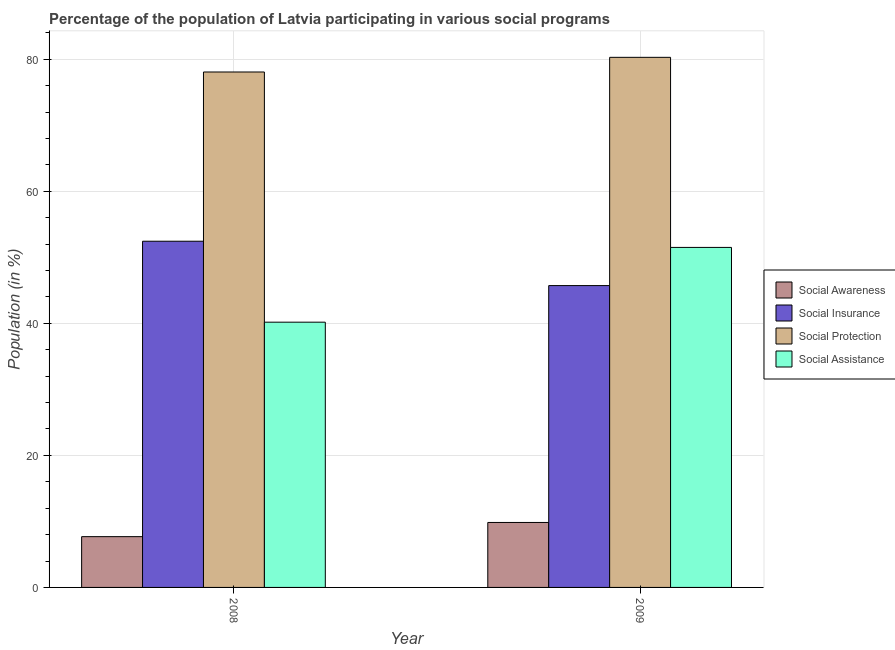How many different coloured bars are there?
Give a very brief answer. 4. How many groups of bars are there?
Your response must be concise. 2. Are the number of bars per tick equal to the number of legend labels?
Provide a succinct answer. Yes. How many bars are there on the 1st tick from the left?
Give a very brief answer. 4. How many bars are there on the 1st tick from the right?
Provide a succinct answer. 4. In how many cases, is the number of bars for a given year not equal to the number of legend labels?
Your answer should be compact. 0. What is the participation of population in social insurance programs in 2008?
Offer a terse response. 52.44. Across all years, what is the maximum participation of population in social insurance programs?
Your answer should be very brief. 52.44. Across all years, what is the minimum participation of population in social assistance programs?
Offer a terse response. 40.18. In which year was the participation of population in social protection programs maximum?
Ensure brevity in your answer.  2009. What is the total participation of population in social protection programs in the graph?
Make the answer very short. 158.38. What is the difference between the participation of population in social awareness programs in 2008 and that in 2009?
Your answer should be very brief. -2.15. What is the difference between the participation of population in social assistance programs in 2008 and the participation of population in social awareness programs in 2009?
Your answer should be very brief. -11.33. What is the average participation of population in social awareness programs per year?
Your answer should be very brief. 8.77. In how many years, is the participation of population in social insurance programs greater than 12 %?
Provide a succinct answer. 2. What is the ratio of the participation of population in social awareness programs in 2008 to that in 2009?
Give a very brief answer. 0.78. In how many years, is the participation of population in social assistance programs greater than the average participation of population in social assistance programs taken over all years?
Make the answer very short. 1. What does the 3rd bar from the left in 2008 represents?
Provide a short and direct response. Social Protection. What does the 2nd bar from the right in 2009 represents?
Your answer should be very brief. Social Protection. Is it the case that in every year, the sum of the participation of population in social awareness programs and participation of population in social insurance programs is greater than the participation of population in social protection programs?
Provide a short and direct response. No. What is the difference between two consecutive major ticks on the Y-axis?
Give a very brief answer. 20. Does the graph contain any zero values?
Your response must be concise. No. Does the graph contain grids?
Offer a terse response. Yes. Where does the legend appear in the graph?
Provide a succinct answer. Center right. How many legend labels are there?
Your response must be concise. 4. How are the legend labels stacked?
Your answer should be compact. Vertical. What is the title of the graph?
Provide a short and direct response. Percentage of the population of Latvia participating in various social programs . Does "Industry" appear as one of the legend labels in the graph?
Provide a short and direct response. No. What is the label or title of the X-axis?
Provide a succinct answer. Year. What is the Population (in %) in Social Awareness in 2008?
Keep it short and to the point. 7.69. What is the Population (in %) of Social Insurance in 2008?
Provide a succinct answer. 52.44. What is the Population (in %) of Social Protection in 2008?
Your answer should be compact. 78.08. What is the Population (in %) of Social Assistance in 2008?
Provide a short and direct response. 40.18. What is the Population (in %) in Social Awareness in 2009?
Keep it short and to the point. 9.84. What is the Population (in %) of Social Insurance in 2009?
Your answer should be very brief. 45.72. What is the Population (in %) in Social Protection in 2009?
Your answer should be compact. 80.3. What is the Population (in %) in Social Assistance in 2009?
Your response must be concise. 51.51. Across all years, what is the maximum Population (in %) in Social Awareness?
Provide a short and direct response. 9.84. Across all years, what is the maximum Population (in %) in Social Insurance?
Your answer should be compact. 52.44. Across all years, what is the maximum Population (in %) in Social Protection?
Make the answer very short. 80.3. Across all years, what is the maximum Population (in %) of Social Assistance?
Offer a very short reply. 51.51. Across all years, what is the minimum Population (in %) of Social Awareness?
Offer a very short reply. 7.69. Across all years, what is the minimum Population (in %) in Social Insurance?
Provide a short and direct response. 45.72. Across all years, what is the minimum Population (in %) in Social Protection?
Provide a succinct answer. 78.08. Across all years, what is the minimum Population (in %) of Social Assistance?
Provide a short and direct response. 40.18. What is the total Population (in %) in Social Awareness in the graph?
Provide a succinct answer. 17.53. What is the total Population (in %) in Social Insurance in the graph?
Ensure brevity in your answer.  98.17. What is the total Population (in %) in Social Protection in the graph?
Make the answer very short. 158.38. What is the total Population (in %) of Social Assistance in the graph?
Offer a very short reply. 91.69. What is the difference between the Population (in %) of Social Awareness in 2008 and that in 2009?
Offer a terse response. -2.15. What is the difference between the Population (in %) in Social Insurance in 2008 and that in 2009?
Offer a very short reply. 6.72. What is the difference between the Population (in %) of Social Protection in 2008 and that in 2009?
Make the answer very short. -2.22. What is the difference between the Population (in %) in Social Assistance in 2008 and that in 2009?
Ensure brevity in your answer.  -11.33. What is the difference between the Population (in %) of Social Awareness in 2008 and the Population (in %) of Social Insurance in 2009?
Ensure brevity in your answer.  -38.03. What is the difference between the Population (in %) of Social Awareness in 2008 and the Population (in %) of Social Protection in 2009?
Make the answer very short. -72.61. What is the difference between the Population (in %) in Social Awareness in 2008 and the Population (in %) in Social Assistance in 2009?
Keep it short and to the point. -43.81. What is the difference between the Population (in %) of Social Insurance in 2008 and the Population (in %) of Social Protection in 2009?
Your answer should be compact. -27.86. What is the difference between the Population (in %) in Social Insurance in 2008 and the Population (in %) in Social Assistance in 2009?
Make the answer very short. 0.94. What is the difference between the Population (in %) of Social Protection in 2008 and the Population (in %) of Social Assistance in 2009?
Give a very brief answer. 26.57. What is the average Population (in %) of Social Awareness per year?
Ensure brevity in your answer.  8.77. What is the average Population (in %) in Social Insurance per year?
Your response must be concise. 49.08. What is the average Population (in %) in Social Protection per year?
Provide a short and direct response. 79.19. What is the average Population (in %) of Social Assistance per year?
Your answer should be compact. 45.84. In the year 2008, what is the difference between the Population (in %) in Social Awareness and Population (in %) in Social Insurance?
Provide a short and direct response. -44.75. In the year 2008, what is the difference between the Population (in %) of Social Awareness and Population (in %) of Social Protection?
Offer a very short reply. -70.39. In the year 2008, what is the difference between the Population (in %) in Social Awareness and Population (in %) in Social Assistance?
Give a very brief answer. -32.49. In the year 2008, what is the difference between the Population (in %) in Social Insurance and Population (in %) in Social Protection?
Your answer should be very brief. -25.64. In the year 2008, what is the difference between the Population (in %) in Social Insurance and Population (in %) in Social Assistance?
Make the answer very short. 12.26. In the year 2008, what is the difference between the Population (in %) of Social Protection and Population (in %) of Social Assistance?
Offer a very short reply. 37.9. In the year 2009, what is the difference between the Population (in %) of Social Awareness and Population (in %) of Social Insurance?
Provide a short and direct response. -35.88. In the year 2009, what is the difference between the Population (in %) of Social Awareness and Population (in %) of Social Protection?
Make the answer very short. -70.46. In the year 2009, what is the difference between the Population (in %) in Social Awareness and Population (in %) in Social Assistance?
Ensure brevity in your answer.  -41.67. In the year 2009, what is the difference between the Population (in %) of Social Insurance and Population (in %) of Social Protection?
Make the answer very short. -34.58. In the year 2009, what is the difference between the Population (in %) in Social Insurance and Population (in %) in Social Assistance?
Provide a succinct answer. -5.78. In the year 2009, what is the difference between the Population (in %) in Social Protection and Population (in %) in Social Assistance?
Your response must be concise. 28.8. What is the ratio of the Population (in %) of Social Awareness in 2008 to that in 2009?
Keep it short and to the point. 0.78. What is the ratio of the Population (in %) in Social Insurance in 2008 to that in 2009?
Your answer should be very brief. 1.15. What is the ratio of the Population (in %) in Social Protection in 2008 to that in 2009?
Provide a short and direct response. 0.97. What is the ratio of the Population (in %) in Social Assistance in 2008 to that in 2009?
Ensure brevity in your answer.  0.78. What is the difference between the highest and the second highest Population (in %) in Social Awareness?
Offer a terse response. 2.15. What is the difference between the highest and the second highest Population (in %) in Social Insurance?
Offer a terse response. 6.72. What is the difference between the highest and the second highest Population (in %) in Social Protection?
Your answer should be very brief. 2.22. What is the difference between the highest and the second highest Population (in %) of Social Assistance?
Offer a terse response. 11.33. What is the difference between the highest and the lowest Population (in %) of Social Awareness?
Make the answer very short. 2.15. What is the difference between the highest and the lowest Population (in %) of Social Insurance?
Provide a short and direct response. 6.72. What is the difference between the highest and the lowest Population (in %) in Social Protection?
Offer a terse response. 2.22. What is the difference between the highest and the lowest Population (in %) of Social Assistance?
Provide a succinct answer. 11.33. 